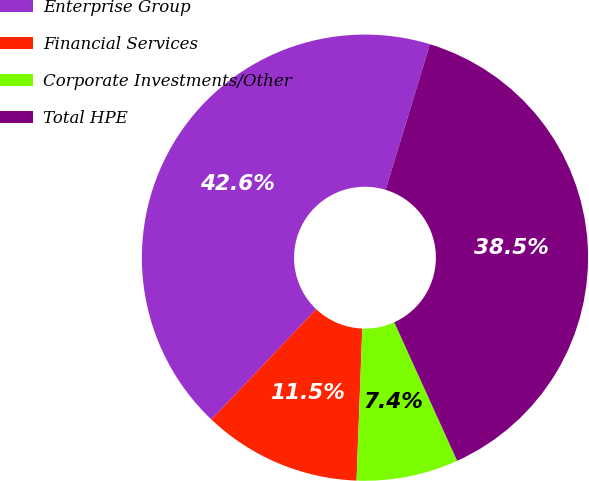<chart> <loc_0><loc_0><loc_500><loc_500><pie_chart><fcel>Enterprise Group<fcel>Financial Services<fcel>Corporate Investments/Other<fcel>Total HPE<nl><fcel>42.62%<fcel>11.48%<fcel>7.38%<fcel>38.52%<nl></chart> 